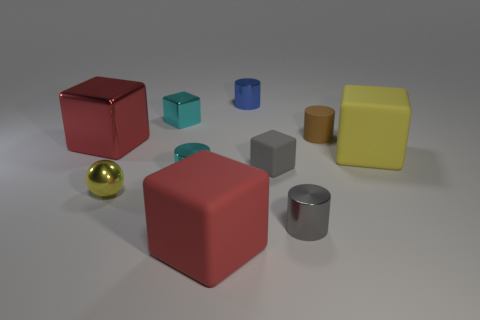What shape is the blue object that is the same size as the yellow shiny thing?
Provide a short and direct response. Cylinder. Is there a gray rubber object of the same shape as the small blue metallic thing?
Your answer should be very brief. No. Is the small brown object made of the same material as the large red thing that is behind the ball?
Your answer should be compact. No. Is there a tiny matte cylinder of the same color as the ball?
Ensure brevity in your answer.  No. How many other objects are the same material as the small gray cylinder?
Keep it short and to the point. 5. There is a tiny shiny cube; is it the same color as the big rubber cube that is right of the brown matte cylinder?
Make the answer very short. No. Are there more blue cylinders in front of the brown rubber cylinder than tiny rubber cylinders?
Provide a succinct answer. No. What number of yellow spheres are in front of the shiny cylinder that is behind the large rubber object right of the tiny brown thing?
Provide a short and direct response. 1. There is a tiny cyan metal thing that is in front of the tiny gray matte cube; is it the same shape as the yellow metal thing?
Offer a very short reply. No. What material is the cube that is behind the brown matte cylinder?
Offer a terse response. Metal. 